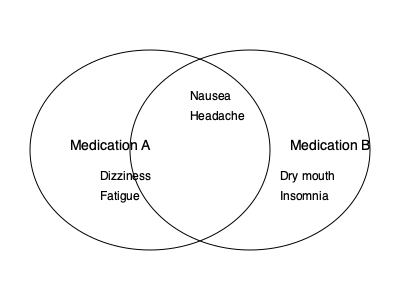Based on the Venn diagram comparing side effects of two similar medications, how many side effects are unique to Medication B? To answer this question, we need to follow these steps:

1. Identify all side effects shown in the Venn diagram:
   - Nausea (shared)
   - Headache (shared)
   - Dizziness (Medication A only)
   - Fatigue (Medication A only)
   - Dry mouth (Medication B only)
   - Insomnia (Medication B only)

2. Determine which side effects are unique to Medication B:
   - Dry mouth
   - Insomnia

3. Count the number of side effects unique to Medication B:
   $2$ side effects are unique to Medication B.

This information is crucial for a digital marketing manager in a pharmaceutical company to understand the differentiating factors between similar medications and to effectively communicate the benefits and risks to healthcare providers and patients.
Answer: 2 